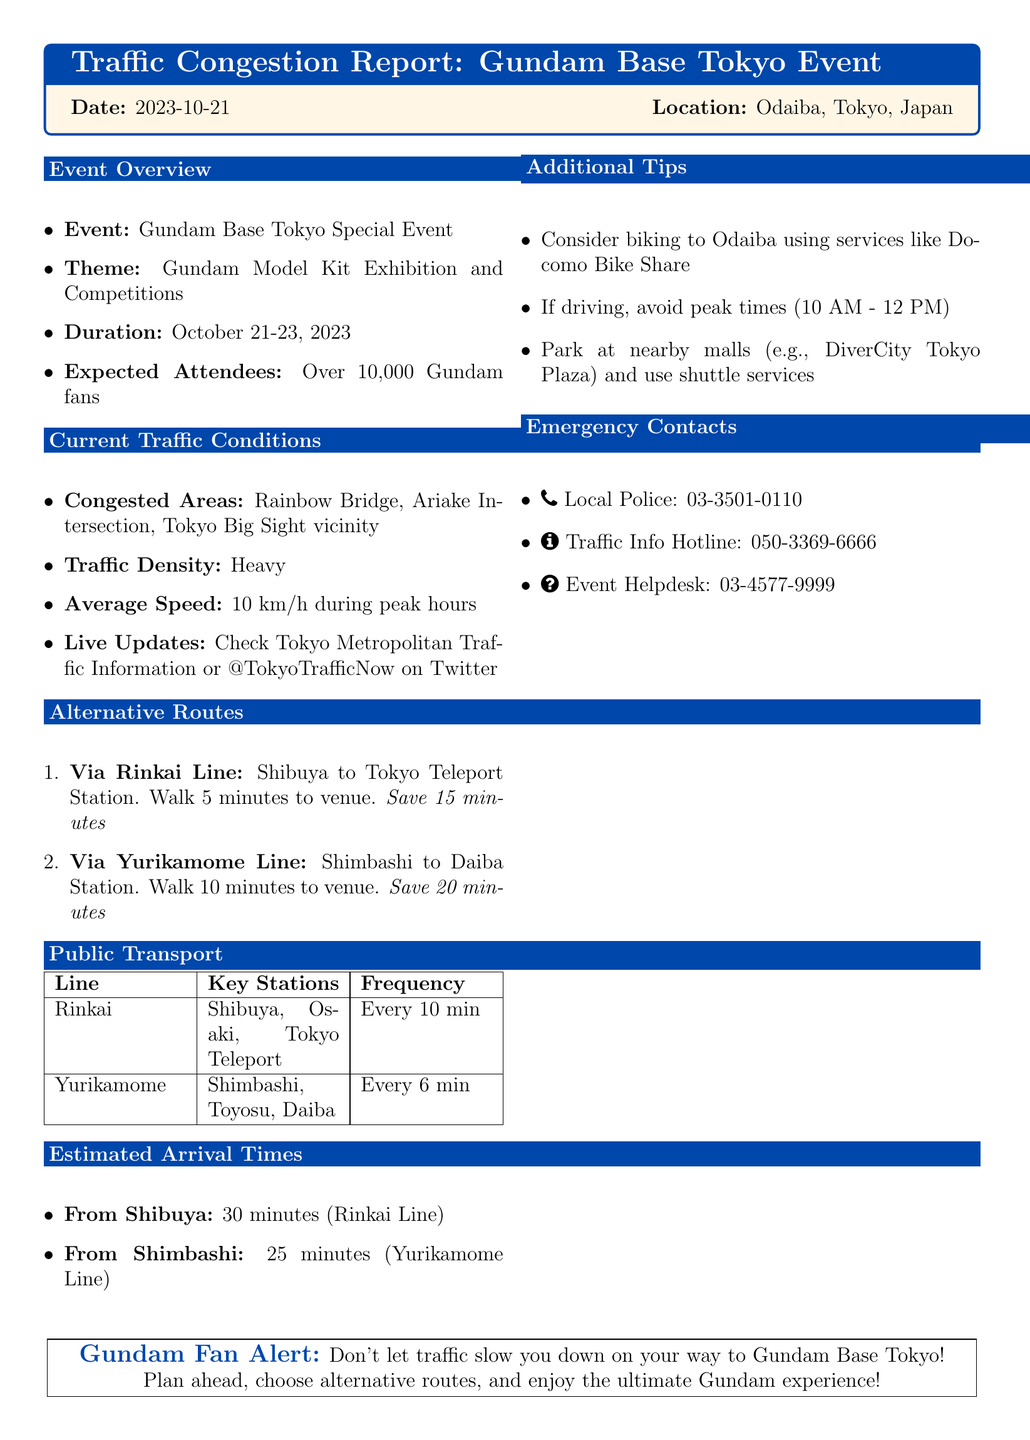What is the date of the event? The date of the event is stated as October 21-23, 2023.
Answer: October 21-23, 2023 How many attendees are expected? The document mentions that there are expected over 10,000 Gundam fans attending the event.
Answer: Over 10,000 What is the average speed during peak hours? The report specifies that the average speed is 10 km/h during peak hours.
Answer: 10 km/h What is one alternative route via public transport? The document lists alternative routes, one being via Rinkai Line from Shibuya to Tokyo Teleport Station.
Answer: Rinkai Line How much time can you save by taking the Yurikamome Line? The document states that taking the Yurikamome Line saves 20 minutes compared to other routes.
Answer: Save 20 minutes What is the frequency of the Yurikamome Line? The report indicates that the frequency of the Yurikamome Line is every 6 minutes.
Answer: Every 6 min Is there a recommendation for biking? The report suggests considering biking to Odaiba using services like Docomo Bike Share.
Answer: Yes What specific areas are congested? The document lists Rainbow Bridge, Ariake Intersection, and Tokyo Big Sight vicinity as congested areas.
Answer: Rainbow Bridge, Ariake Intersection, Tokyo Big Sight vicinity What is the local police contact number? The emergency contacts section provides the local police number as 03-3501-0110.
Answer: 03-3501-0110 